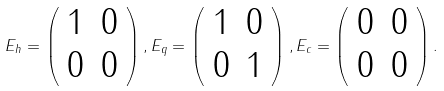Convert formula to latex. <formula><loc_0><loc_0><loc_500><loc_500>E _ { h } = \left ( \begin{array} { c c } 1 & 0 \\ 0 & 0 \end{array} \right ) , E _ { q } = \left ( \begin{array} { c c } 1 & 0 \\ 0 & 1 \end{array} \right ) , E _ { c } = \left ( \begin{array} { c c } 0 & 0 \\ 0 & 0 \end{array} \right ) .</formula> 